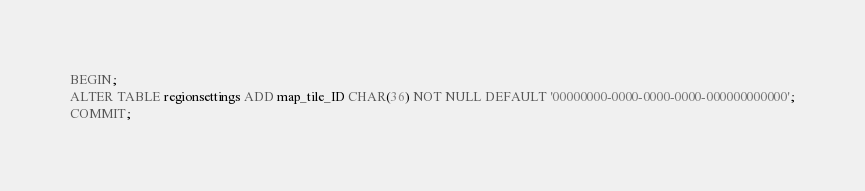<code> <loc_0><loc_0><loc_500><loc_500><_SQL_>BEGIN;
ALTER TABLE regionsettings ADD map_tile_ID CHAR(36) NOT NULL DEFAULT '00000000-0000-0000-0000-000000000000';
COMMIT;
</code> 